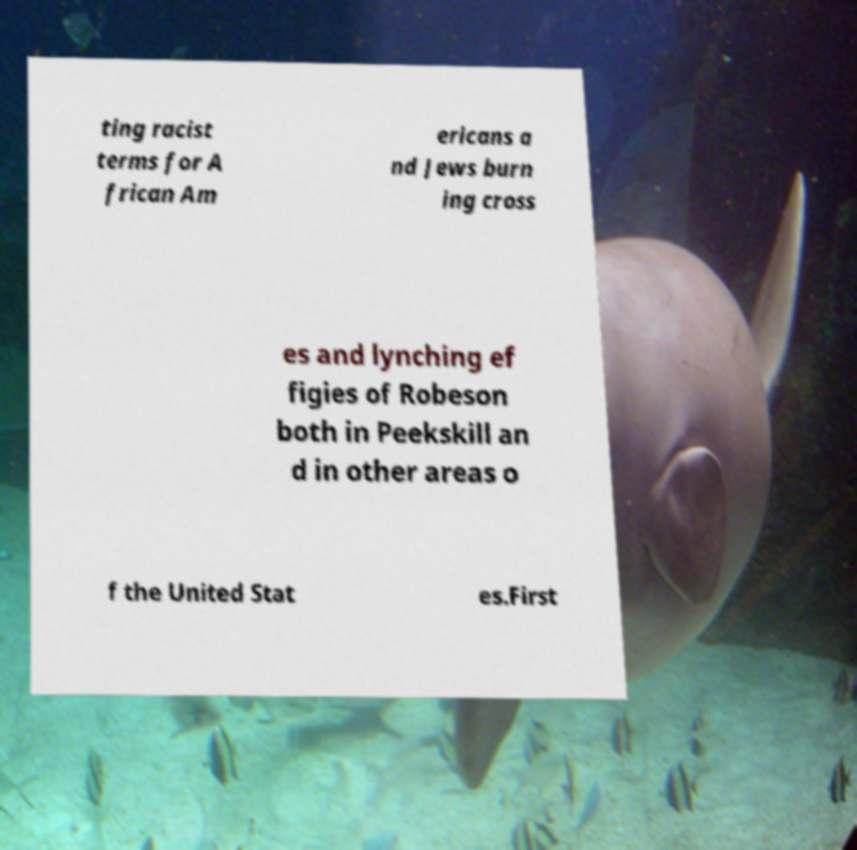I need the written content from this picture converted into text. Can you do that? ting racist terms for A frican Am ericans a nd Jews burn ing cross es and lynching ef figies of Robeson both in Peekskill an d in other areas o f the United Stat es.First 